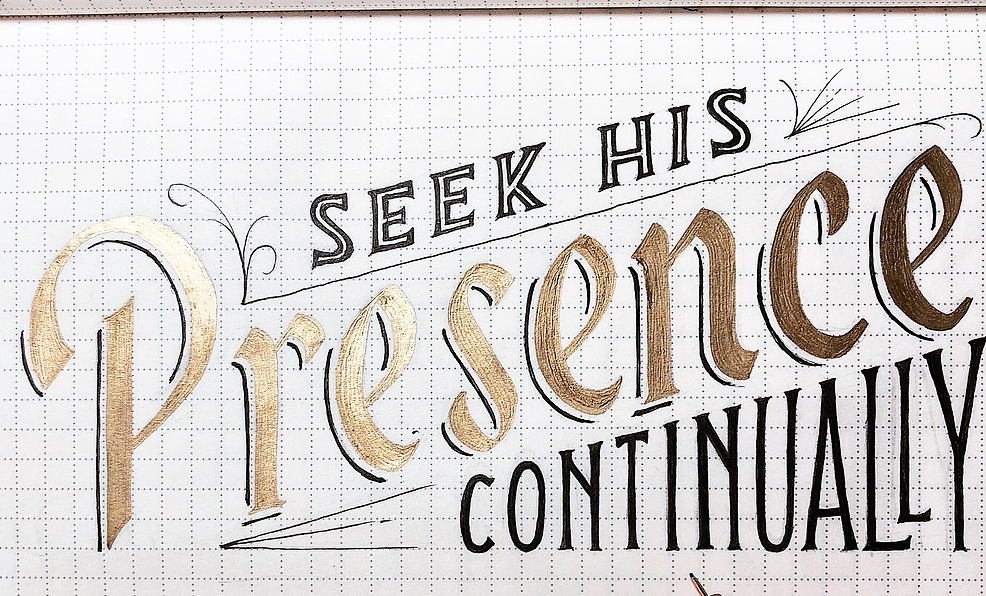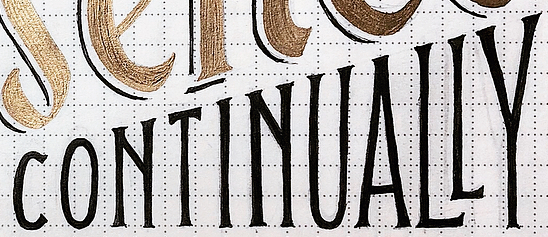Read the text content from these images in order, separated by a semicolon. Presence; CONTINUALLY 